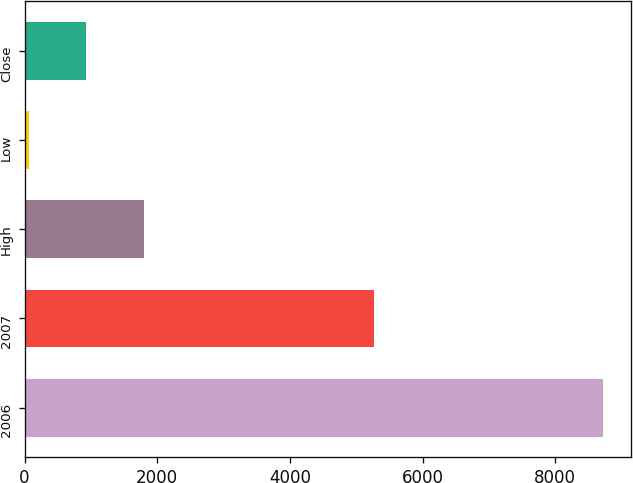Convert chart to OTSL. <chart><loc_0><loc_0><loc_500><loc_500><bar_chart><fcel>2006<fcel>2007<fcel>High<fcel>Low<fcel>Close<nl><fcel>8714<fcel>5265<fcel>1792.85<fcel>62.57<fcel>927.71<nl></chart> 